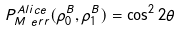Convert formula to latex. <formula><loc_0><loc_0><loc_500><loc_500>P _ { M \text { } e r r } ^ { A l i c e } ( \rho _ { 0 } ^ { B } , \rho _ { 1 } ^ { B } ) = \cos ^ { 2 } 2 \theta</formula> 